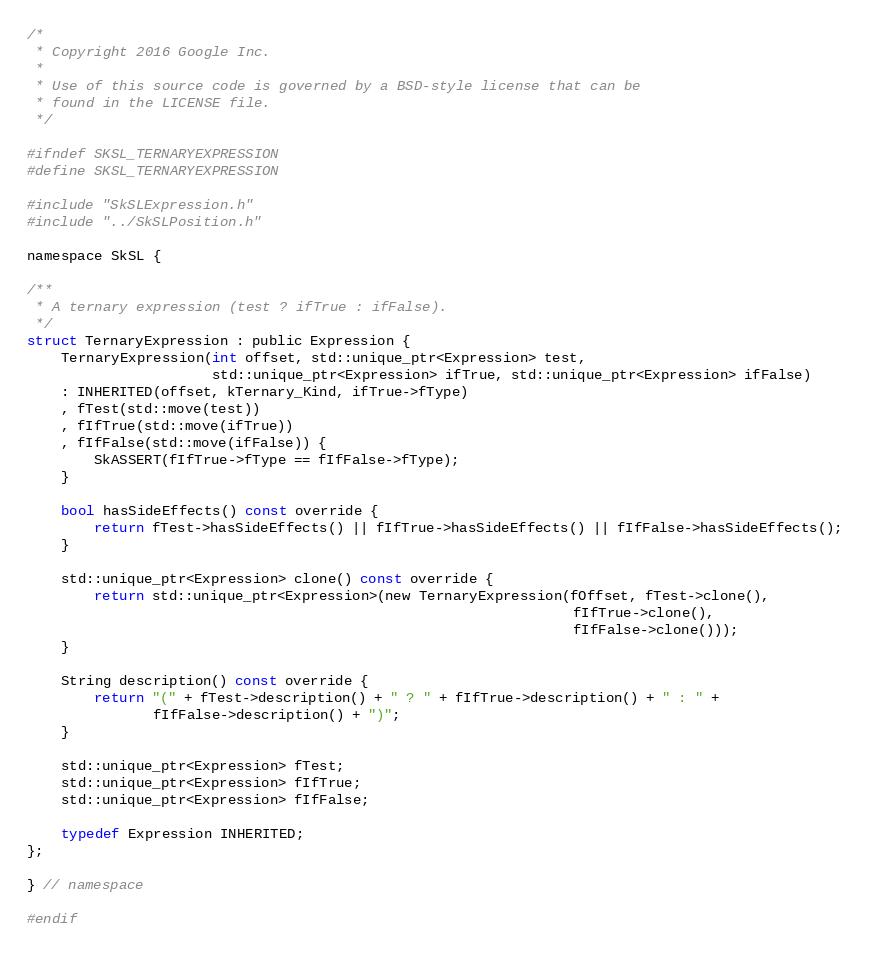<code> <loc_0><loc_0><loc_500><loc_500><_C_>/*
 * Copyright 2016 Google Inc.
 *
 * Use of this source code is governed by a BSD-style license that can be
 * found in the LICENSE file.
 */

#ifndef SKSL_TERNARYEXPRESSION
#define SKSL_TERNARYEXPRESSION

#include "SkSLExpression.h"
#include "../SkSLPosition.h"

namespace SkSL {

/**
 * A ternary expression (test ? ifTrue : ifFalse).
 */
struct TernaryExpression : public Expression {
    TernaryExpression(int offset, std::unique_ptr<Expression> test,
                      std::unique_ptr<Expression> ifTrue, std::unique_ptr<Expression> ifFalse)
    : INHERITED(offset, kTernary_Kind, ifTrue->fType)
    , fTest(std::move(test))
    , fIfTrue(std::move(ifTrue))
    , fIfFalse(std::move(ifFalse)) {
        SkASSERT(fIfTrue->fType == fIfFalse->fType);
    }

    bool hasSideEffects() const override {
        return fTest->hasSideEffects() || fIfTrue->hasSideEffects() || fIfFalse->hasSideEffects();
    }

    std::unique_ptr<Expression> clone() const override {
        return std::unique_ptr<Expression>(new TernaryExpression(fOffset, fTest->clone(),
                                                                 fIfTrue->clone(),
                                                                 fIfFalse->clone()));
    }

    String description() const override {
        return "(" + fTest->description() + " ? " + fIfTrue->description() + " : " +
               fIfFalse->description() + ")";
    }

    std::unique_ptr<Expression> fTest;
    std::unique_ptr<Expression> fIfTrue;
    std::unique_ptr<Expression> fIfFalse;

    typedef Expression INHERITED;
};

} // namespace

#endif
</code> 